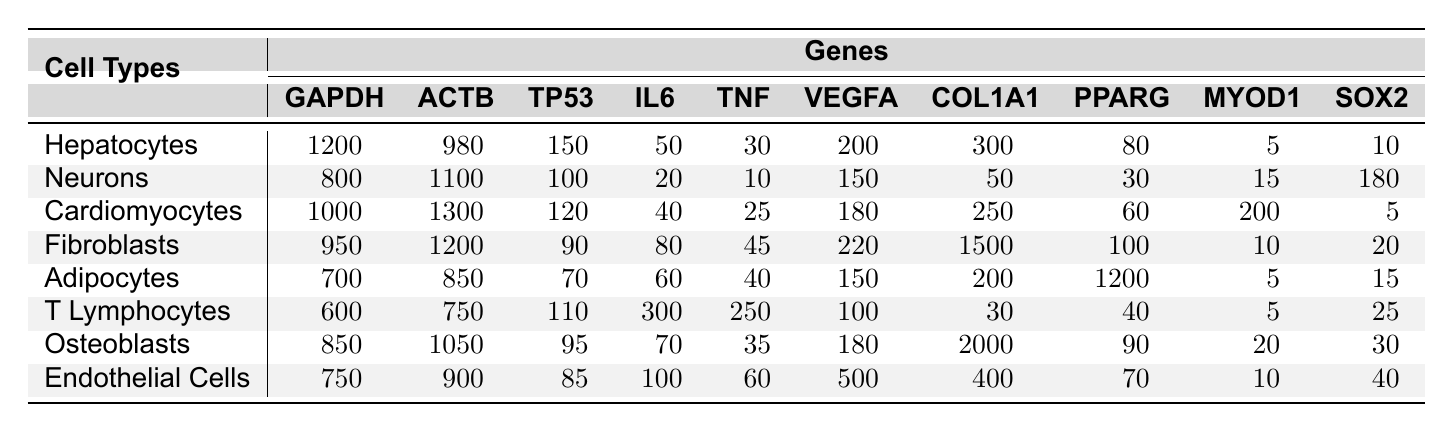What is the expression level of GAPDH in Hepatocytes? The table lists the expression levels for different genes in Hepatocytes, showing 1200 for GAPDH.
Answer: 1200 Which cell type has the highest expression level of COL1A1? In the table, the values for COL1A1 across cell types show that Fibroblasts have the highest level at 1500.
Answer: Fibroblasts What is the average expression level of TP53 across all cell types? To find the average, add the TP53 values: (150 + 100 + 120 + 90 + 70 + 110 + 95 + 85) = 1,020. There are 8 cell types, so the average is 1,020 / 8 = 127.5.
Answer: 127.5 Do Neurons have a higher expression level of IL6 than T Lymphocytes? The table shows that Neurons have an IL6 level of 20, while T Lymphocytes have an IL6 level of 300, indicating that T Lymphocytes have a higher expression level of IL6.
Answer: No What is the difference in expression levels of VEGFA between Cardiomyocytes and Adipocytes? Cardiomyocytes have a VEGFA level of 180, while Adipocytes have a VEGFA level of 150. The difference is 180 - 150 = 30.
Answer: 30 Which gene has the lowest expression level in Endothelial Cells? Looking at the expression levels for Endothelial Cells, the lowest value is for SOX2, which is 40.
Answer: SOX2 What is the total expression level of TNF across all cell types? Sum the TNF values for each cell type: 30 + 10 + 25 + 45 + 40 + 250 + 35 + 60 = 495.
Answer: 495 How many cell types have an expression level of MYOD1 greater than 50? The expression levels of MYOD1 are 10, 180, 5, 20, 15, 25, 30, and 40. Only three cell types—Neurons, Cardiomyocytes, and Adipocytes—have levels greater than 50.
Answer: 3 What is the highest expression level of any gene across all the cell types listed? Analyzing the highest values in the expression data shows the peak value is 2000 from the COL1A1 gene expressed in Osteoblasts.
Answer: 2000 Which cell type has the lowest expression level of GAPDH? The GAPDH levels for each cell type show that T Lymphocytes have the lowest level at 600.
Answer: T Lymphocytes 